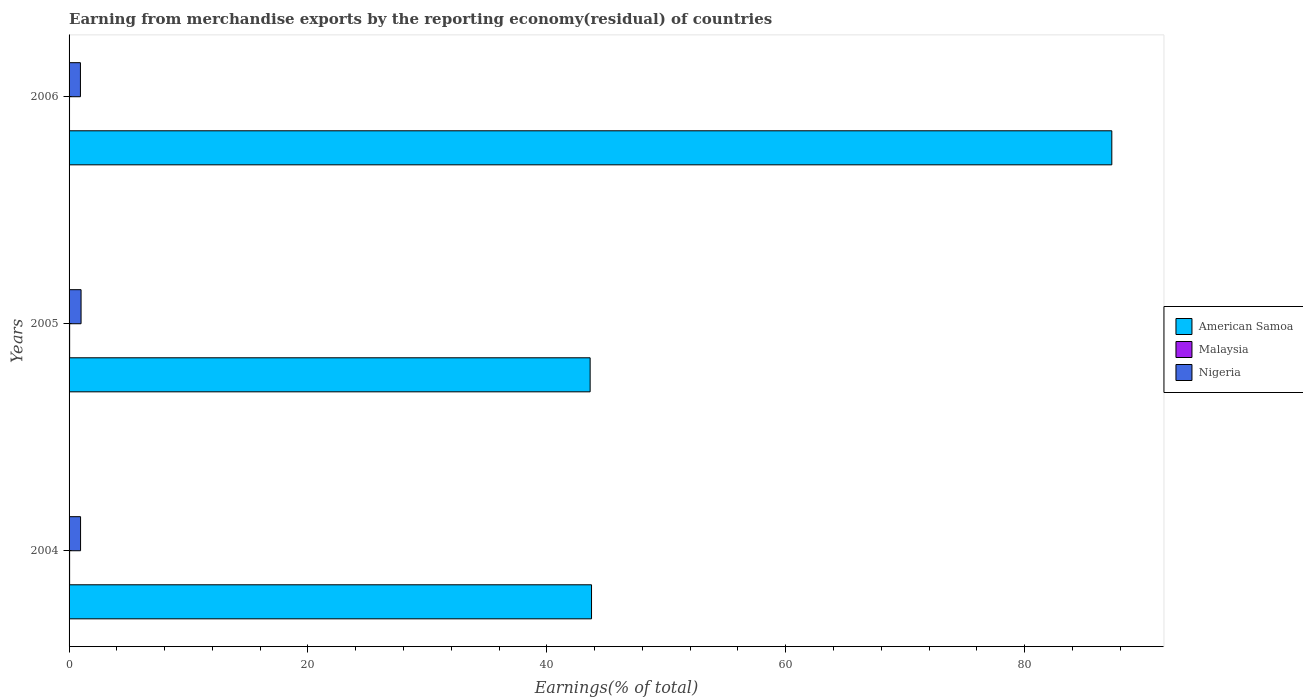What is the percentage of amount earned from merchandise exports in Nigeria in 2005?
Provide a succinct answer. 1. Across all years, what is the maximum percentage of amount earned from merchandise exports in Malaysia?
Offer a terse response. 0.05. Across all years, what is the minimum percentage of amount earned from merchandise exports in Nigeria?
Keep it short and to the point. 0.95. In which year was the percentage of amount earned from merchandise exports in Malaysia maximum?
Your response must be concise. 2005. What is the total percentage of amount earned from merchandise exports in Malaysia in the graph?
Provide a short and direct response. 0.13. What is the difference between the percentage of amount earned from merchandise exports in American Samoa in 2005 and that in 2006?
Your answer should be compact. -43.67. What is the difference between the percentage of amount earned from merchandise exports in American Samoa in 2004 and the percentage of amount earned from merchandise exports in Malaysia in 2006?
Make the answer very short. 43.7. What is the average percentage of amount earned from merchandise exports in Malaysia per year?
Your answer should be compact. 0.04. In the year 2006, what is the difference between the percentage of amount earned from merchandise exports in Nigeria and percentage of amount earned from merchandise exports in Malaysia?
Provide a short and direct response. 0.91. What is the ratio of the percentage of amount earned from merchandise exports in Malaysia in 2004 to that in 2005?
Provide a succinct answer. 0.95. What is the difference between the highest and the second highest percentage of amount earned from merchandise exports in Nigeria?
Give a very brief answer. 0.04. What is the difference between the highest and the lowest percentage of amount earned from merchandise exports in Malaysia?
Offer a terse response. 0.01. In how many years, is the percentage of amount earned from merchandise exports in Nigeria greater than the average percentage of amount earned from merchandise exports in Nigeria taken over all years?
Make the answer very short. 1. What does the 3rd bar from the top in 2004 represents?
Keep it short and to the point. American Samoa. What does the 1st bar from the bottom in 2004 represents?
Offer a very short reply. American Samoa. Is it the case that in every year, the sum of the percentage of amount earned from merchandise exports in Nigeria and percentage of amount earned from merchandise exports in American Samoa is greater than the percentage of amount earned from merchandise exports in Malaysia?
Provide a short and direct response. Yes. How many bars are there?
Provide a succinct answer. 9. How many years are there in the graph?
Your answer should be compact. 3. What is the difference between two consecutive major ticks on the X-axis?
Keep it short and to the point. 20. Are the values on the major ticks of X-axis written in scientific E-notation?
Offer a terse response. No. Does the graph contain any zero values?
Give a very brief answer. No. Where does the legend appear in the graph?
Ensure brevity in your answer.  Center right. How many legend labels are there?
Make the answer very short. 3. What is the title of the graph?
Offer a very short reply. Earning from merchandise exports by the reporting economy(residual) of countries. Does "Cuba" appear as one of the legend labels in the graph?
Ensure brevity in your answer.  No. What is the label or title of the X-axis?
Ensure brevity in your answer.  Earnings(% of total). What is the Earnings(% of total) in American Samoa in 2004?
Offer a very short reply. 43.74. What is the Earnings(% of total) of Malaysia in 2004?
Keep it short and to the point. 0.05. What is the Earnings(% of total) in Nigeria in 2004?
Offer a terse response. 0.96. What is the Earnings(% of total) of American Samoa in 2005?
Offer a terse response. 43.62. What is the Earnings(% of total) in Malaysia in 2005?
Your answer should be very brief. 0.05. What is the Earnings(% of total) of Nigeria in 2005?
Your response must be concise. 1. What is the Earnings(% of total) in American Samoa in 2006?
Your answer should be compact. 87.3. What is the Earnings(% of total) of Malaysia in 2006?
Offer a very short reply. 0.04. What is the Earnings(% of total) in Nigeria in 2006?
Keep it short and to the point. 0.95. Across all years, what is the maximum Earnings(% of total) in American Samoa?
Keep it short and to the point. 87.3. Across all years, what is the maximum Earnings(% of total) in Malaysia?
Make the answer very short. 0.05. Across all years, what is the maximum Earnings(% of total) in Nigeria?
Give a very brief answer. 1. Across all years, what is the minimum Earnings(% of total) in American Samoa?
Give a very brief answer. 43.62. Across all years, what is the minimum Earnings(% of total) of Malaysia?
Make the answer very short. 0.04. Across all years, what is the minimum Earnings(% of total) in Nigeria?
Ensure brevity in your answer.  0.95. What is the total Earnings(% of total) in American Samoa in the graph?
Provide a succinct answer. 174.66. What is the total Earnings(% of total) of Malaysia in the graph?
Offer a terse response. 0.13. What is the total Earnings(% of total) in Nigeria in the graph?
Your response must be concise. 2.92. What is the difference between the Earnings(% of total) in American Samoa in 2004 and that in 2005?
Offer a terse response. 0.12. What is the difference between the Earnings(% of total) in Malaysia in 2004 and that in 2005?
Give a very brief answer. -0. What is the difference between the Earnings(% of total) of Nigeria in 2004 and that in 2005?
Provide a succinct answer. -0.04. What is the difference between the Earnings(% of total) of American Samoa in 2004 and that in 2006?
Make the answer very short. -43.56. What is the difference between the Earnings(% of total) in Malaysia in 2004 and that in 2006?
Your answer should be compact. 0.01. What is the difference between the Earnings(% of total) of Nigeria in 2004 and that in 2006?
Give a very brief answer. 0.01. What is the difference between the Earnings(% of total) in American Samoa in 2005 and that in 2006?
Ensure brevity in your answer.  -43.67. What is the difference between the Earnings(% of total) in Malaysia in 2005 and that in 2006?
Offer a terse response. 0.01. What is the difference between the Earnings(% of total) of Nigeria in 2005 and that in 2006?
Keep it short and to the point. 0.05. What is the difference between the Earnings(% of total) of American Samoa in 2004 and the Earnings(% of total) of Malaysia in 2005?
Your answer should be compact. 43.69. What is the difference between the Earnings(% of total) in American Samoa in 2004 and the Earnings(% of total) in Nigeria in 2005?
Offer a very short reply. 42.74. What is the difference between the Earnings(% of total) in Malaysia in 2004 and the Earnings(% of total) in Nigeria in 2005?
Provide a succinct answer. -0.96. What is the difference between the Earnings(% of total) of American Samoa in 2004 and the Earnings(% of total) of Malaysia in 2006?
Keep it short and to the point. 43.7. What is the difference between the Earnings(% of total) in American Samoa in 2004 and the Earnings(% of total) in Nigeria in 2006?
Ensure brevity in your answer.  42.79. What is the difference between the Earnings(% of total) in Malaysia in 2004 and the Earnings(% of total) in Nigeria in 2006?
Offer a terse response. -0.91. What is the difference between the Earnings(% of total) in American Samoa in 2005 and the Earnings(% of total) in Malaysia in 2006?
Keep it short and to the point. 43.59. What is the difference between the Earnings(% of total) of American Samoa in 2005 and the Earnings(% of total) of Nigeria in 2006?
Your answer should be very brief. 42.67. What is the difference between the Earnings(% of total) of Malaysia in 2005 and the Earnings(% of total) of Nigeria in 2006?
Your answer should be compact. -0.9. What is the average Earnings(% of total) of American Samoa per year?
Ensure brevity in your answer.  58.22. What is the average Earnings(% of total) in Malaysia per year?
Ensure brevity in your answer.  0.04. What is the average Earnings(% of total) in Nigeria per year?
Offer a very short reply. 0.97. In the year 2004, what is the difference between the Earnings(% of total) of American Samoa and Earnings(% of total) of Malaysia?
Offer a terse response. 43.7. In the year 2004, what is the difference between the Earnings(% of total) in American Samoa and Earnings(% of total) in Nigeria?
Offer a very short reply. 42.78. In the year 2004, what is the difference between the Earnings(% of total) of Malaysia and Earnings(% of total) of Nigeria?
Provide a succinct answer. -0.92. In the year 2005, what is the difference between the Earnings(% of total) in American Samoa and Earnings(% of total) in Malaysia?
Ensure brevity in your answer.  43.58. In the year 2005, what is the difference between the Earnings(% of total) of American Samoa and Earnings(% of total) of Nigeria?
Your response must be concise. 42.62. In the year 2005, what is the difference between the Earnings(% of total) of Malaysia and Earnings(% of total) of Nigeria?
Provide a short and direct response. -0.96. In the year 2006, what is the difference between the Earnings(% of total) of American Samoa and Earnings(% of total) of Malaysia?
Your response must be concise. 87.26. In the year 2006, what is the difference between the Earnings(% of total) of American Samoa and Earnings(% of total) of Nigeria?
Provide a short and direct response. 86.35. In the year 2006, what is the difference between the Earnings(% of total) of Malaysia and Earnings(% of total) of Nigeria?
Your answer should be compact. -0.91. What is the ratio of the Earnings(% of total) of American Samoa in 2004 to that in 2005?
Your answer should be very brief. 1. What is the ratio of the Earnings(% of total) of Malaysia in 2004 to that in 2005?
Give a very brief answer. 0.95. What is the ratio of the Earnings(% of total) of Nigeria in 2004 to that in 2005?
Offer a very short reply. 0.96. What is the ratio of the Earnings(% of total) of American Samoa in 2004 to that in 2006?
Your answer should be compact. 0.5. What is the ratio of the Earnings(% of total) of Malaysia in 2004 to that in 2006?
Make the answer very short. 1.16. What is the ratio of the Earnings(% of total) in Nigeria in 2004 to that in 2006?
Ensure brevity in your answer.  1.01. What is the ratio of the Earnings(% of total) in American Samoa in 2005 to that in 2006?
Provide a succinct answer. 0.5. What is the ratio of the Earnings(% of total) in Malaysia in 2005 to that in 2006?
Your response must be concise. 1.23. What is the ratio of the Earnings(% of total) in Nigeria in 2005 to that in 2006?
Provide a short and direct response. 1.05. What is the difference between the highest and the second highest Earnings(% of total) of American Samoa?
Your response must be concise. 43.56. What is the difference between the highest and the second highest Earnings(% of total) in Malaysia?
Keep it short and to the point. 0. What is the difference between the highest and the second highest Earnings(% of total) in Nigeria?
Give a very brief answer. 0.04. What is the difference between the highest and the lowest Earnings(% of total) of American Samoa?
Offer a very short reply. 43.67. What is the difference between the highest and the lowest Earnings(% of total) in Malaysia?
Your answer should be very brief. 0.01. What is the difference between the highest and the lowest Earnings(% of total) in Nigeria?
Keep it short and to the point. 0.05. 